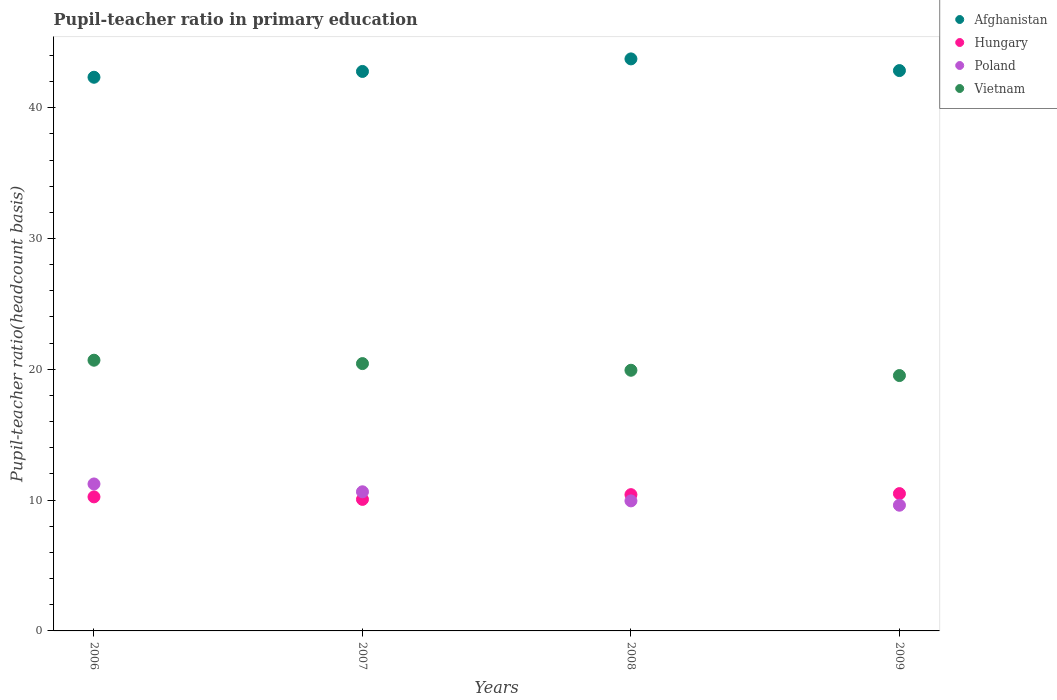How many different coloured dotlines are there?
Provide a short and direct response. 4. What is the pupil-teacher ratio in primary education in Hungary in 2009?
Keep it short and to the point. 10.5. Across all years, what is the maximum pupil-teacher ratio in primary education in Vietnam?
Offer a terse response. 20.69. Across all years, what is the minimum pupil-teacher ratio in primary education in Poland?
Offer a terse response. 9.61. In which year was the pupil-teacher ratio in primary education in Vietnam maximum?
Make the answer very short. 2006. In which year was the pupil-teacher ratio in primary education in Vietnam minimum?
Your answer should be very brief. 2009. What is the total pupil-teacher ratio in primary education in Poland in the graph?
Your answer should be compact. 41.42. What is the difference between the pupil-teacher ratio in primary education in Vietnam in 2007 and that in 2008?
Provide a short and direct response. 0.51. What is the difference between the pupil-teacher ratio in primary education in Poland in 2006 and the pupil-teacher ratio in primary education in Vietnam in 2008?
Give a very brief answer. -8.69. What is the average pupil-teacher ratio in primary education in Vietnam per year?
Offer a terse response. 20.15. In the year 2008, what is the difference between the pupil-teacher ratio in primary education in Afghanistan and pupil-teacher ratio in primary education in Vietnam?
Your answer should be very brief. 23.8. In how many years, is the pupil-teacher ratio in primary education in Afghanistan greater than 34?
Your response must be concise. 4. What is the ratio of the pupil-teacher ratio in primary education in Hungary in 2007 to that in 2008?
Provide a succinct answer. 0.97. Is the pupil-teacher ratio in primary education in Afghanistan in 2008 less than that in 2009?
Your answer should be very brief. No. Is the difference between the pupil-teacher ratio in primary education in Afghanistan in 2006 and 2007 greater than the difference between the pupil-teacher ratio in primary education in Vietnam in 2006 and 2007?
Your answer should be very brief. No. What is the difference between the highest and the second highest pupil-teacher ratio in primary education in Poland?
Your answer should be very brief. 0.6. What is the difference between the highest and the lowest pupil-teacher ratio in primary education in Hungary?
Ensure brevity in your answer.  0.44. Is it the case that in every year, the sum of the pupil-teacher ratio in primary education in Hungary and pupil-teacher ratio in primary education in Afghanistan  is greater than the sum of pupil-teacher ratio in primary education in Poland and pupil-teacher ratio in primary education in Vietnam?
Offer a terse response. Yes. Is it the case that in every year, the sum of the pupil-teacher ratio in primary education in Hungary and pupil-teacher ratio in primary education in Vietnam  is greater than the pupil-teacher ratio in primary education in Afghanistan?
Your answer should be compact. No. Does the pupil-teacher ratio in primary education in Afghanistan monotonically increase over the years?
Offer a very short reply. No. Is the pupil-teacher ratio in primary education in Vietnam strictly greater than the pupil-teacher ratio in primary education in Poland over the years?
Give a very brief answer. Yes. Is the pupil-teacher ratio in primary education in Vietnam strictly less than the pupil-teacher ratio in primary education in Hungary over the years?
Provide a succinct answer. No. How many dotlines are there?
Keep it short and to the point. 4. How many years are there in the graph?
Keep it short and to the point. 4. Are the values on the major ticks of Y-axis written in scientific E-notation?
Keep it short and to the point. No. Does the graph contain any zero values?
Your answer should be very brief. No. Where does the legend appear in the graph?
Your answer should be compact. Top right. What is the title of the graph?
Your response must be concise. Pupil-teacher ratio in primary education. Does "Fiji" appear as one of the legend labels in the graph?
Your response must be concise. No. What is the label or title of the Y-axis?
Keep it short and to the point. Pupil-teacher ratio(headcount basis). What is the Pupil-teacher ratio(headcount basis) of Afghanistan in 2006?
Your answer should be very brief. 42.33. What is the Pupil-teacher ratio(headcount basis) in Hungary in 2006?
Your answer should be compact. 10.25. What is the Pupil-teacher ratio(headcount basis) of Poland in 2006?
Keep it short and to the point. 11.23. What is the Pupil-teacher ratio(headcount basis) in Vietnam in 2006?
Offer a very short reply. 20.69. What is the Pupil-teacher ratio(headcount basis) of Afghanistan in 2007?
Make the answer very short. 42.77. What is the Pupil-teacher ratio(headcount basis) in Hungary in 2007?
Keep it short and to the point. 10.06. What is the Pupil-teacher ratio(headcount basis) of Poland in 2007?
Give a very brief answer. 10.64. What is the Pupil-teacher ratio(headcount basis) of Vietnam in 2007?
Your answer should be compact. 20.44. What is the Pupil-teacher ratio(headcount basis) of Afghanistan in 2008?
Make the answer very short. 43.73. What is the Pupil-teacher ratio(headcount basis) of Hungary in 2008?
Provide a succinct answer. 10.42. What is the Pupil-teacher ratio(headcount basis) of Poland in 2008?
Provide a short and direct response. 9.94. What is the Pupil-teacher ratio(headcount basis) in Vietnam in 2008?
Your response must be concise. 19.93. What is the Pupil-teacher ratio(headcount basis) of Afghanistan in 2009?
Offer a terse response. 42.84. What is the Pupil-teacher ratio(headcount basis) of Hungary in 2009?
Give a very brief answer. 10.5. What is the Pupil-teacher ratio(headcount basis) in Poland in 2009?
Provide a short and direct response. 9.61. What is the Pupil-teacher ratio(headcount basis) in Vietnam in 2009?
Keep it short and to the point. 19.52. Across all years, what is the maximum Pupil-teacher ratio(headcount basis) in Afghanistan?
Keep it short and to the point. 43.73. Across all years, what is the maximum Pupil-teacher ratio(headcount basis) of Hungary?
Offer a terse response. 10.5. Across all years, what is the maximum Pupil-teacher ratio(headcount basis) of Poland?
Your response must be concise. 11.23. Across all years, what is the maximum Pupil-teacher ratio(headcount basis) of Vietnam?
Ensure brevity in your answer.  20.69. Across all years, what is the minimum Pupil-teacher ratio(headcount basis) of Afghanistan?
Make the answer very short. 42.33. Across all years, what is the minimum Pupil-teacher ratio(headcount basis) in Hungary?
Your response must be concise. 10.06. Across all years, what is the minimum Pupil-teacher ratio(headcount basis) of Poland?
Offer a very short reply. 9.61. Across all years, what is the minimum Pupil-teacher ratio(headcount basis) of Vietnam?
Ensure brevity in your answer.  19.52. What is the total Pupil-teacher ratio(headcount basis) in Afghanistan in the graph?
Keep it short and to the point. 171.66. What is the total Pupil-teacher ratio(headcount basis) of Hungary in the graph?
Give a very brief answer. 41.22. What is the total Pupil-teacher ratio(headcount basis) in Poland in the graph?
Give a very brief answer. 41.42. What is the total Pupil-teacher ratio(headcount basis) of Vietnam in the graph?
Keep it short and to the point. 80.58. What is the difference between the Pupil-teacher ratio(headcount basis) in Afghanistan in 2006 and that in 2007?
Offer a terse response. -0.44. What is the difference between the Pupil-teacher ratio(headcount basis) in Hungary in 2006 and that in 2007?
Offer a very short reply. 0.19. What is the difference between the Pupil-teacher ratio(headcount basis) of Poland in 2006 and that in 2007?
Ensure brevity in your answer.  0.6. What is the difference between the Pupil-teacher ratio(headcount basis) in Vietnam in 2006 and that in 2007?
Ensure brevity in your answer.  0.26. What is the difference between the Pupil-teacher ratio(headcount basis) of Afghanistan in 2006 and that in 2008?
Provide a succinct answer. -1.4. What is the difference between the Pupil-teacher ratio(headcount basis) of Hungary in 2006 and that in 2008?
Provide a short and direct response. -0.17. What is the difference between the Pupil-teacher ratio(headcount basis) in Poland in 2006 and that in 2008?
Make the answer very short. 1.29. What is the difference between the Pupil-teacher ratio(headcount basis) of Vietnam in 2006 and that in 2008?
Your answer should be compact. 0.77. What is the difference between the Pupil-teacher ratio(headcount basis) in Afghanistan in 2006 and that in 2009?
Your answer should be compact. -0.51. What is the difference between the Pupil-teacher ratio(headcount basis) of Hungary in 2006 and that in 2009?
Provide a succinct answer. -0.25. What is the difference between the Pupil-teacher ratio(headcount basis) of Poland in 2006 and that in 2009?
Make the answer very short. 1.62. What is the difference between the Pupil-teacher ratio(headcount basis) of Vietnam in 2006 and that in 2009?
Offer a very short reply. 1.17. What is the difference between the Pupil-teacher ratio(headcount basis) of Afghanistan in 2007 and that in 2008?
Your answer should be compact. -0.96. What is the difference between the Pupil-teacher ratio(headcount basis) of Hungary in 2007 and that in 2008?
Offer a very short reply. -0.36. What is the difference between the Pupil-teacher ratio(headcount basis) in Poland in 2007 and that in 2008?
Ensure brevity in your answer.  0.69. What is the difference between the Pupil-teacher ratio(headcount basis) of Vietnam in 2007 and that in 2008?
Your answer should be very brief. 0.51. What is the difference between the Pupil-teacher ratio(headcount basis) of Afghanistan in 2007 and that in 2009?
Offer a terse response. -0.07. What is the difference between the Pupil-teacher ratio(headcount basis) of Hungary in 2007 and that in 2009?
Offer a very short reply. -0.44. What is the difference between the Pupil-teacher ratio(headcount basis) in Poland in 2007 and that in 2009?
Offer a terse response. 1.03. What is the difference between the Pupil-teacher ratio(headcount basis) in Vietnam in 2007 and that in 2009?
Your response must be concise. 0.91. What is the difference between the Pupil-teacher ratio(headcount basis) in Afghanistan in 2008 and that in 2009?
Give a very brief answer. 0.89. What is the difference between the Pupil-teacher ratio(headcount basis) in Hungary in 2008 and that in 2009?
Your response must be concise. -0.08. What is the difference between the Pupil-teacher ratio(headcount basis) in Poland in 2008 and that in 2009?
Your response must be concise. 0.33. What is the difference between the Pupil-teacher ratio(headcount basis) in Vietnam in 2008 and that in 2009?
Your answer should be very brief. 0.4. What is the difference between the Pupil-teacher ratio(headcount basis) in Afghanistan in 2006 and the Pupil-teacher ratio(headcount basis) in Hungary in 2007?
Your answer should be very brief. 32.27. What is the difference between the Pupil-teacher ratio(headcount basis) of Afghanistan in 2006 and the Pupil-teacher ratio(headcount basis) of Poland in 2007?
Offer a very short reply. 31.69. What is the difference between the Pupil-teacher ratio(headcount basis) in Afghanistan in 2006 and the Pupil-teacher ratio(headcount basis) in Vietnam in 2007?
Offer a terse response. 21.89. What is the difference between the Pupil-teacher ratio(headcount basis) in Hungary in 2006 and the Pupil-teacher ratio(headcount basis) in Poland in 2007?
Your answer should be very brief. -0.39. What is the difference between the Pupil-teacher ratio(headcount basis) in Hungary in 2006 and the Pupil-teacher ratio(headcount basis) in Vietnam in 2007?
Provide a succinct answer. -10.19. What is the difference between the Pupil-teacher ratio(headcount basis) in Poland in 2006 and the Pupil-teacher ratio(headcount basis) in Vietnam in 2007?
Ensure brevity in your answer.  -9.2. What is the difference between the Pupil-teacher ratio(headcount basis) in Afghanistan in 2006 and the Pupil-teacher ratio(headcount basis) in Hungary in 2008?
Your answer should be very brief. 31.91. What is the difference between the Pupil-teacher ratio(headcount basis) of Afghanistan in 2006 and the Pupil-teacher ratio(headcount basis) of Poland in 2008?
Ensure brevity in your answer.  32.38. What is the difference between the Pupil-teacher ratio(headcount basis) in Afghanistan in 2006 and the Pupil-teacher ratio(headcount basis) in Vietnam in 2008?
Provide a short and direct response. 22.4. What is the difference between the Pupil-teacher ratio(headcount basis) of Hungary in 2006 and the Pupil-teacher ratio(headcount basis) of Poland in 2008?
Offer a terse response. 0.31. What is the difference between the Pupil-teacher ratio(headcount basis) in Hungary in 2006 and the Pupil-teacher ratio(headcount basis) in Vietnam in 2008?
Keep it short and to the point. -9.68. What is the difference between the Pupil-teacher ratio(headcount basis) in Poland in 2006 and the Pupil-teacher ratio(headcount basis) in Vietnam in 2008?
Your response must be concise. -8.69. What is the difference between the Pupil-teacher ratio(headcount basis) in Afghanistan in 2006 and the Pupil-teacher ratio(headcount basis) in Hungary in 2009?
Your answer should be very brief. 31.83. What is the difference between the Pupil-teacher ratio(headcount basis) of Afghanistan in 2006 and the Pupil-teacher ratio(headcount basis) of Poland in 2009?
Give a very brief answer. 32.72. What is the difference between the Pupil-teacher ratio(headcount basis) of Afghanistan in 2006 and the Pupil-teacher ratio(headcount basis) of Vietnam in 2009?
Keep it short and to the point. 22.8. What is the difference between the Pupil-teacher ratio(headcount basis) in Hungary in 2006 and the Pupil-teacher ratio(headcount basis) in Poland in 2009?
Ensure brevity in your answer.  0.64. What is the difference between the Pupil-teacher ratio(headcount basis) in Hungary in 2006 and the Pupil-teacher ratio(headcount basis) in Vietnam in 2009?
Keep it short and to the point. -9.27. What is the difference between the Pupil-teacher ratio(headcount basis) in Poland in 2006 and the Pupil-teacher ratio(headcount basis) in Vietnam in 2009?
Offer a terse response. -8.29. What is the difference between the Pupil-teacher ratio(headcount basis) of Afghanistan in 2007 and the Pupil-teacher ratio(headcount basis) of Hungary in 2008?
Offer a terse response. 32.35. What is the difference between the Pupil-teacher ratio(headcount basis) of Afghanistan in 2007 and the Pupil-teacher ratio(headcount basis) of Poland in 2008?
Provide a short and direct response. 32.83. What is the difference between the Pupil-teacher ratio(headcount basis) in Afghanistan in 2007 and the Pupil-teacher ratio(headcount basis) in Vietnam in 2008?
Ensure brevity in your answer.  22.84. What is the difference between the Pupil-teacher ratio(headcount basis) of Hungary in 2007 and the Pupil-teacher ratio(headcount basis) of Poland in 2008?
Your answer should be compact. 0.11. What is the difference between the Pupil-teacher ratio(headcount basis) of Hungary in 2007 and the Pupil-teacher ratio(headcount basis) of Vietnam in 2008?
Ensure brevity in your answer.  -9.87. What is the difference between the Pupil-teacher ratio(headcount basis) of Poland in 2007 and the Pupil-teacher ratio(headcount basis) of Vietnam in 2008?
Ensure brevity in your answer.  -9.29. What is the difference between the Pupil-teacher ratio(headcount basis) in Afghanistan in 2007 and the Pupil-teacher ratio(headcount basis) in Hungary in 2009?
Provide a succinct answer. 32.27. What is the difference between the Pupil-teacher ratio(headcount basis) in Afghanistan in 2007 and the Pupil-teacher ratio(headcount basis) in Poland in 2009?
Provide a succinct answer. 33.16. What is the difference between the Pupil-teacher ratio(headcount basis) in Afghanistan in 2007 and the Pupil-teacher ratio(headcount basis) in Vietnam in 2009?
Your response must be concise. 23.25. What is the difference between the Pupil-teacher ratio(headcount basis) of Hungary in 2007 and the Pupil-teacher ratio(headcount basis) of Poland in 2009?
Ensure brevity in your answer.  0.44. What is the difference between the Pupil-teacher ratio(headcount basis) of Hungary in 2007 and the Pupil-teacher ratio(headcount basis) of Vietnam in 2009?
Ensure brevity in your answer.  -9.47. What is the difference between the Pupil-teacher ratio(headcount basis) of Poland in 2007 and the Pupil-teacher ratio(headcount basis) of Vietnam in 2009?
Your response must be concise. -8.89. What is the difference between the Pupil-teacher ratio(headcount basis) of Afghanistan in 2008 and the Pupil-teacher ratio(headcount basis) of Hungary in 2009?
Provide a short and direct response. 33.23. What is the difference between the Pupil-teacher ratio(headcount basis) in Afghanistan in 2008 and the Pupil-teacher ratio(headcount basis) in Poland in 2009?
Your answer should be very brief. 34.12. What is the difference between the Pupil-teacher ratio(headcount basis) in Afghanistan in 2008 and the Pupil-teacher ratio(headcount basis) in Vietnam in 2009?
Keep it short and to the point. 24.21. What is the difference between the Pupil-teacher ratio(headcount basis) in Hungary in 2008 and the Pupil-teacher ratio(headcount basis) in Poland in 2009?
Your response must be concise. 0.81. What is the difference between the Pupil-teacher ratio(headcount basis) of Hungary in 2008 and the Pupil-teacher ratio(headcount basis) of Vietnam in 2009?
Give a very brief answer. -9.1. What is the difference between the Pupil-teacher ratio(headcount basis) of Poland in 2008 and the Pupil-teacher ratio(headcount basis) of Vietnam in 2009?
Ensure brevity in your answer.  -9.58. What is the average Pupil-teacher ratio(headcount basis) in Afghanistan per year?
Your answer should be very brief. 42.92. What is the average Pupil-teacher ratio(headcount basis) of Hungary per year?
Your response must be concise. 10.3. What is the average Pupil-teacher ratio(headcount basis) of Poland per year?
Your answer should be very brief. 10.36. What is the average Pupil-teacher ratio(headcount basis) in Vietnam per year?
Offer a very short reply. 20.14. In the year 2006, what is the difference between the Pupil-teacher ratio(headcount basis) of Afghanistan and Pupil-teacher ratio(headcount basis) of Hungary?
Your response must be concise. 32.08. In the year 2006, what is the difference between the Pupil-teacher ratio(headcount basis) of Afghanistan and Pupil-teacher ratio(headcount basis) of Poland?
Provide a succinct answer. 31.09. In the year 2006, what is the difference between the Pupil-teacher ratio(headcount basis) in Afghanistan and Pupil-teacher ratio(headcount basis) in Vietnam?
Your response must be concise. 21.63. In the year 2006, what is the difference between the Pupil-teacher ratio(headcount basis) in Hungary and Pupil-teacher ratio(headcount basis) in Poland?
Offer a very short reply. -0.99. In the year 2006, what is the difference between the Pupil-teacher ratio(headcount basis) in Hungary and Pupil-teacher ratio(headcount basis) in Vietnam?
Your answer should be compact. -10.45. In the year 2006, what is the difference between the Pupil-teacher ratio(headcount basis) in Poland and Pupil-teacher ratio(headcount basis) in Vietnam?
Keep it short and to the point. -9.46. In the year 2007, what is the difference between the Pupil-teacher ratio(headcount basis) in Afghanistan and Pupil-teacher ratio(headcount basis) in Hungary?
Your answer should be compact. 32.72. In the year 2007, what is the difference between the Pupil-teacher ratio(headcount basis) in Afghanistan and Pupil-teacher ratio(headcount basis) in Poland?
Make the answer very short. 32.13. In the year 2007, what is the difference between the Pupil-teacher ratio(headcount basis) in Afghanistan and Pupil-teacher ratio(headcount basis) in Vietnam?
Keep it short and to the point. 22.33. In the year 2007, what is the difference between the Pupil-teacher ratio(headcount basis) in Hungary and Pupil-teacher ratio(headcount basis) in Poland?
Provide a succinct answer. -0.58. In the year 2007, what is the difference between the Pupil-teacher ratio(headcount basis) of Hungary and Pupil-teacher ratio(headcount basis) of Vietnam?
Keep it short and to the point. -10.38. In the year 2007, what is the difference between the Pupil-teacher ratio(headcount basis) of Poland and Pupil-teacher ratio(headcount basis) of Vietnam?
Ensure brevity in your answer.  -9.8. In the year 2008, what is the difference between the Pupil-teacher ratio(headcount basis) of Afghanistan and Pupil-teacher ratio(headcount basis) of Hungary?
Offer a terse response. 33.31. In the year 2008, what is the difference between the Pupil-teacher ratio(headcount basis) in Afghanistan and Pupil-teacher ratio(headcount basis) in Poland?
Offer a very short reply. 33.79. In the year 2008, what is the difference between the Pupil-teacher ratio(headcount basis) in Afghanistan and Pupil-teacher ratio(headcount basis) in Vietnam?
Your answer should be compact. 23.8. In the year 2008, what is the difference between the Pupil-teacher ratio(headcount basis) in Hungary and Pupil-teacher ratio(headcount basis) in Poland?
Your answer should be compact. 0.48. In the year 2008, what is the difference between the Pupil-teacher ratio(headcount basis) in Hungary and Pupil-teacher ratio(headcount basis) in Vietnam?
Give a very brief answer. -9.51. In the year 2008, what is the difference between the Pupil-teacher ratio(headcount basis) in Poland and Pupil-teacher ratio(headcount basis) in Vietnam?
Give a very brief answer. -9.99. In the year 2009, what is the difference between the Pupil-teacher ratio(headcount basis) of Afghanistan and Pupil-teacher ratio(headcount basis) of Hungary?
Offer a terse response. 32.34. In the year 2009, what is the difference between the Pupil-teacher ratio(headcount basis) of Afghanistan and Pupil-teacher ratio(headcount basis) of Poland?
Your answer should be very brief. 33.23. In the year 2009, what is the difference between the Pupil-teacher ratio(headcount basis) of Afghanistan and Pupil-teacher ratio(headcount basis) of Vietnam?
Provide a succinct answer. 23.31. In the year 2009, what is the difference between the Pupil-teacher ratio(headcount basis) in Hungary and Pupil-teacher ratio(headcount basis) in Poland?
Give a very brief answer. 0.89. In the year 2009, what is the difference between the Pupil-teacher ratio(headcount basis) in Hungary and Pupil-teacher ratio(headcount basis) in Vietnam?
Offer a very short reply. -9.03. In the year 2009, what is the difference between the Pupil-teacher ratio(headcount basis) in Poland and Pupil-teacher ratio(headcount basis) in Vietnam?
Make the answer very short. -9.91. What is the ratio of the Pupil-teacher ratio(headcount basis) of Afghanistan in 2006 to that in 2007?
Give a very brief answer. 0.99. What is the ratio of the Pupil-teacher ratio(headcount basis) of Hungary in 2006 to that in 2007?
Provide a succinct answer. 1.02. What is the ratio of the Pupil-teacher ratio(headcount basis) in Poland in 2006 to that in 2007?
Provide a short and direct response. 1.06. What is the ratio of the Pupil-teacher ratio(headcount basis) in Vietnam in 2006 to that in 2007?
Offer a terse response. 1.01. What is the ratio of the Pupil-teacher ratio(headcount basis) in Afghanistan in 2006 to that in 2008?
Give a very brief answer. 0.97. What is the ratio of the Pupil-teacher ratio(headcount basis) of Hungary in 2006 to that in 2008?
Your response must be concise. 0.98. What is the ratio of the Pupil-teacher ratio(headcount basis) of Poland in 2006 to that in 2008?
Make the answer very short. 1.13. What is the ratio of the Pupil-teacher ratio(headcount basis) in Vietnam in 2006 to that in 2008?
Ensure brevity in your answer.  1.04. What is the ratio of the Pupil-teacher ratio(headcount basis) of Afghanistan in 2006 to that in 2009?
Offer a very short reply. 0.99. What is the ratio of the Pupil-teacher ratio(headcount basis) of Hungary in 2006 to that in 2009?
Ensure brevity in your answer.  0.98. What is the ratio of the Pupil-teacher ratio(headcount basis) of Poland in 2006 to that in 2009?
Your answer should be very brief. 1.17. What is the ratio of the Pupil-teacher ratio(headcount basis) in Vietnam in 2006 to that in 2009?
Give a very brief answer. 1.06. What is the ratio of the Pupil-teacher ratio(headcount basis) in Afghanistan in 2007 to that in 2008?
Provide a succinct answer. 0.98. What is the ratio of the Pupil-teacher ratio(headcount basis) of Hungary in 2007 to that in 2008?
Your response must be concise. 0.97. What is the ratio of the Pupil-teacher ratio(headcount basis) of Poland in 2007 to that in 2008?
Your answer should be compact. 1.07. What is the ratio of the Pupil-teacher ratio(headcount basis) in Vietnam in 2007 to that in 2008?
Your response must be concise. 1.03. What is the ratio of the Pupil-teacher ratio(headcount basis) in Hungary in 2007 to that in 2009?
Ensure brevity in your answer.  0.96. What is the ratio of the Pupil-teacher ratio(headcount basis) in Poland in 2007 to that in 2009?
Your answer should be compact. 1.11. What is the ratio of the Pupil-teacher ratio(headcount basis) in Vietnam in 2007 to that in 2009?
Offer a terse response. 1.05. What is the ratio of the Pupil-teacher ratio(headcount basis) in Afghanistan in 2008 to that in 2009?
Your answer should be very brief. 1.02. What is the ratio of the Pupil-teacher ratio(headcount basis) in Poland in 2008 to that in 2009?
Offer a terse response. 1.03. What is the ratio of the Pupil-teacher ratio(headcount basis) in Vietnam in 2008 to that in 2009?
Your response must be concise. 1.02. What is the difference between the highest and the second highest Pupil-teacher ratio(headcount basis) in Afghanistan?
Keep it short and to the point. 0.89. What is the difference between the highest and the second highest Pupil-teacher ratio(headcount basis) of Hungary?
Offer a terse response. 0.08. What is the difference between the highest and the second highest Pupil-teacher ratio(headcount basis) in Poland?
Your answer should be very brief. 0.6. What is the difference between the highest and the second highest Pupil-teacher ratio(headcount basis) in Vietnam?
Provide a short and direct response. 0.26. What is the difference between the highest and the lowest Pupil-teacher ratio(headcount basis) of Afghanistan?
Offer a terse response. 1.4. What is the difference between the highest and the lowest Pupil-teacher ratio(headcount basis) of Hungary?
Provide a succinct answer. 0.44. What is the difference between the highest and the lowest Pupil-teacher ratio(headcount basis) of Poland?
Your answer should be very brief. 1.62. What is the difference between the highest and the lowest Pupil-teacher ratio(headcount basis) in Vietnam?
Offer a terse response. 1.17. 